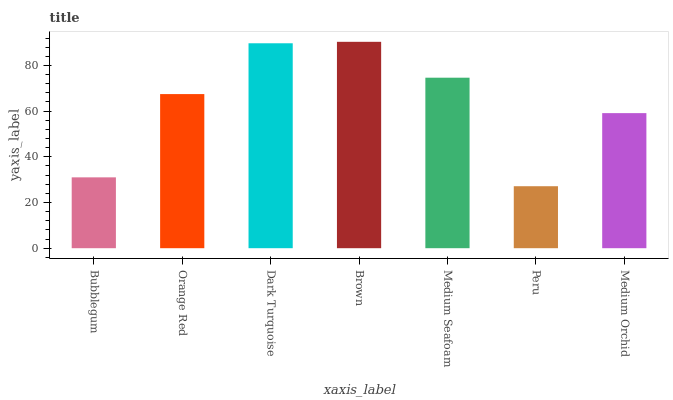Is Peru the minimum?
Answer yes or no. Yes. Is Brown the maximum?
Answer yes or no. Yes. Is Orange Red the minimum?
Answer yes or no. No. Is Orange Red the maximum?
Answer yes or no. No. Is Orange Red greater than Bubblegum?
Answer yes or no. Yes. Is Bubblegum less than Orange Red?
Answer yes or no. Yes. Is Bubblegum greater than Orange Red?
Answer yes or no. No. Is Orange Red less than Bubblegum?
Answer yes or no. No. Is Orange Red the high median?
Answer yes or no. Yes. Is Orange Red the low median?
Answer yes or no. Yes. Is Medium Seafoam the high median?
Answer yes or no. No. Is Dark Turquoise the low median?
Answer yes or no. No. 